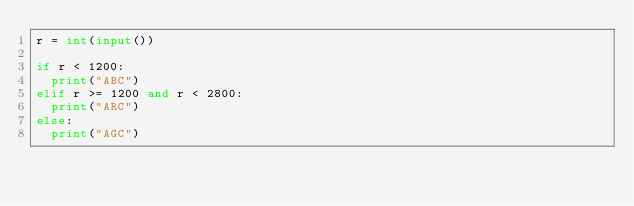<code> <loc_0><loc_0><loc_500><loc_500><_Python_>r = int(input())

if r < 1200:
  print("ABC")
elif r >= 1200 and r < 2800:
  print("ARC")
else:
  print("AGC")</code> 